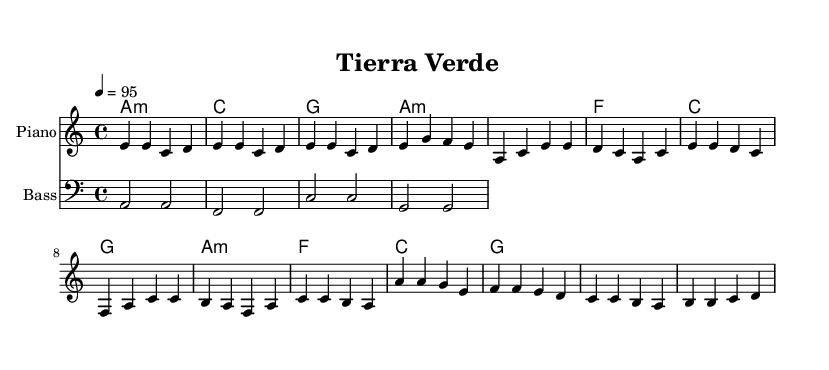What is the key signature of this music? The key signature is A minor, which has no sharps or flats. It can be determined by looking at the signature at the beginning of the musical staff.
Answer: A minor What is the time signature of this music? The time signature is 4/4, indicated by the fraction at the beginning, which specifies four beats in a measure or bar.
Answer: 4/4 What is the tempo marking for this piece? The tempo marking indicates a speed of 95 beats per minute, represented by the number "4 = 95" in the score.
Answer: 95 How many measures are in the Chorus section? The Chorus consists of four measures, which can be identified by counting the bar lines in that section of the music.
Answer: 4 What chords are used in the Verse section? The chords for the Verse are A minor, F, C, and G, found in the chord section under the corresponding measures.
Answer: A minor, F, C, G Which instrument plays the melody in this piece? The melody is played by the Piano, indicated by the staff labeled as "Piano" in the score.
Answer: Piano What type of music genre does this piece represent? This piece represents reggaeton, a music genre characterized by its Latin rhythms and beats, as well as its themes of sustainable living in this context.
Answer: Reggaeton 